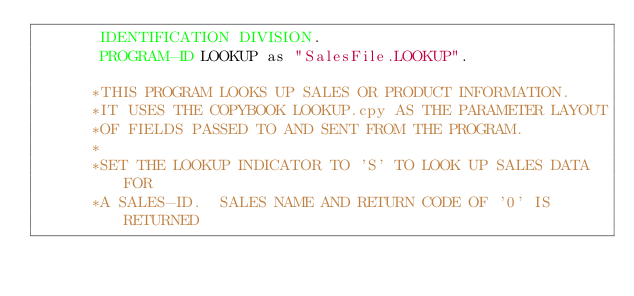Convert code to text. <code><loc_0><loc_0><loc_500><loc_500><_COBOL_>       IDENTIFICATION DIVISION.
       PROGRAM-ID LOOKUP as "SalesFile.LOOKUP".
       
      *THIS PROGRAM LOOKS UP SALES OR PRODUCT INFORMATION.
      *IT USES THE COPYBOOK LOOKUP.cpy AS THE PARAMETER LAYOUT
      *OF FIELDS PASSED TO AND SENT FROM THE PROGRAM.
      *
      *SET THE LOOKUP INDICATOR TO 'S' TO LOOK UP SALES DATA FOR
      *A SALES-ID.  SALES NAME AND RETURN CODE OF '0' IS RETURNED</code> 